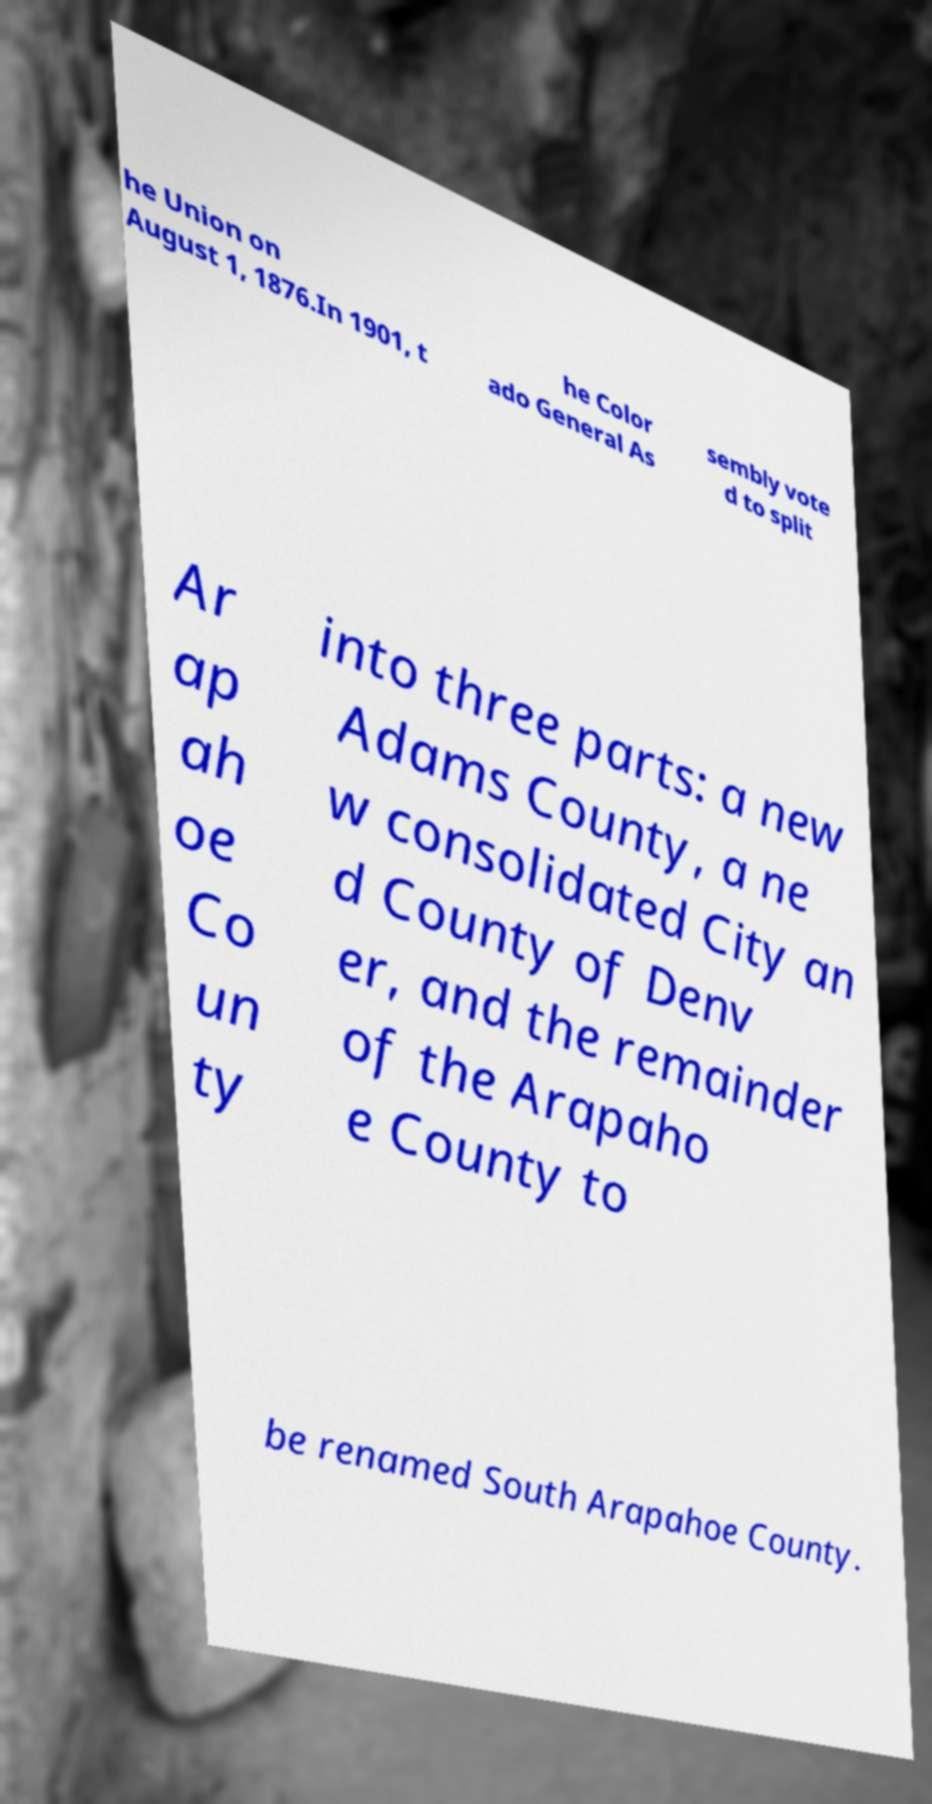Please identify and transcribe the text found in this image. he Union on August 1, 1876.In 1901, t he Color ado General As sembly vote d to split Ar ap ah oe Co un ty into three parts: a new Adams County, a ne w consolidated City an d County of Denv er, and the remainder of the Arapaho e County to be renamed South Arapahoe County. 